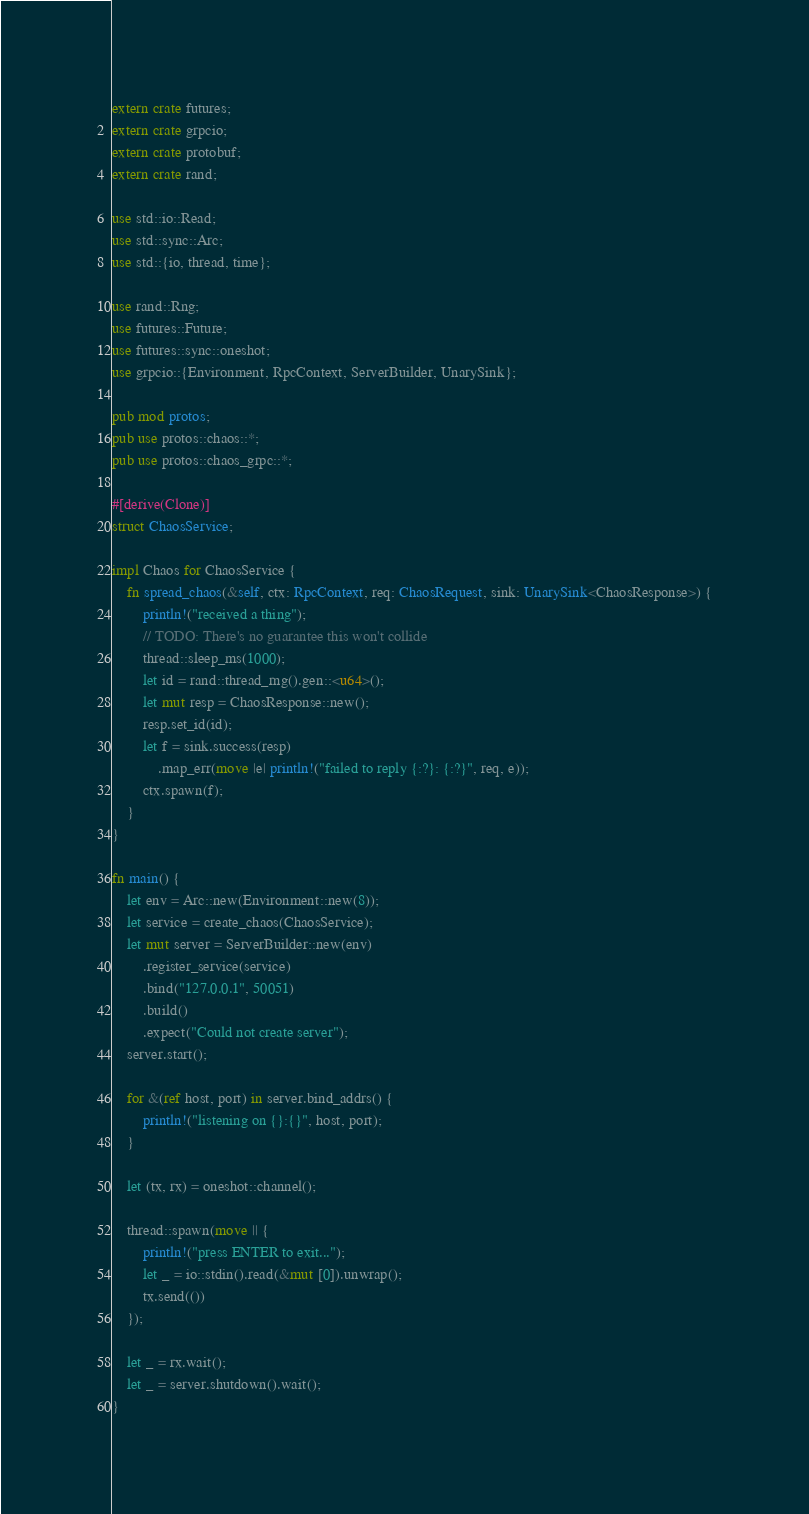<code> <loc_0><loc_0><loc_500><loc_500><_Rust_>extern crate futures;
extern crate grpcio;
extern crate protobuf;
extern crate rand;

use std::io::Read;
use std::sync::Arc;
use std::{io, thread, time};

use rand::Rng;
use futures::Future;
use futures::sync::oneshot;
use grpcio::{Environment, RpcContext, ServerBuilder, UnarySink};

pub mod protos;
pub use protos::chaos::*;
pub use protos::chaos_grpc::*;

#[derive(Clone)]
struct ChaosService;

impl Chaos for ChaosService {
    fn spread_chaos(&self, ctx: RpcContext, req: ChaosRequest, sink: UnarySink<ChaosResponse>) {
        println!("received a thing");
        // TODO: There's no guarantee this won't collide
        thread::sleep_ms(1000);
        let id = rand::thread_rng().gen::<u64>();
        let mut resp = ChaosResponse::new();
        resp.set_id(id);
        let f = sink.success(resp)
            .map_err(move |e| println!("failed to reply {:?}: {:?}", req, e));
        ctx.spawn(f);
    }
}

fn main() {
    let env = Arc::new(Environment::new(8));
    let service = create_chaos(ChaosService);
    let mut server = ServerBuilder::new(env)
        .register_service(service)
        .bind("127.0.0.1", 50051)
        .build()
        .expect("Could not create server");
    server.start();

    for &(ref host, port) in server.bind_addrs() {
        println!("listening on {}:{}", host, port);
    }

    let (tx, rx) = oneshot::channel();

    thread::spawn(move || {
        println!("press ENTER to exit...");
        let _ = io::stdin().read(&mut [0]).unwrap();
        tx.send(())
    });

    let _ = rx.wait();
    let _ = server.shutdown().wait();
}
</code> 